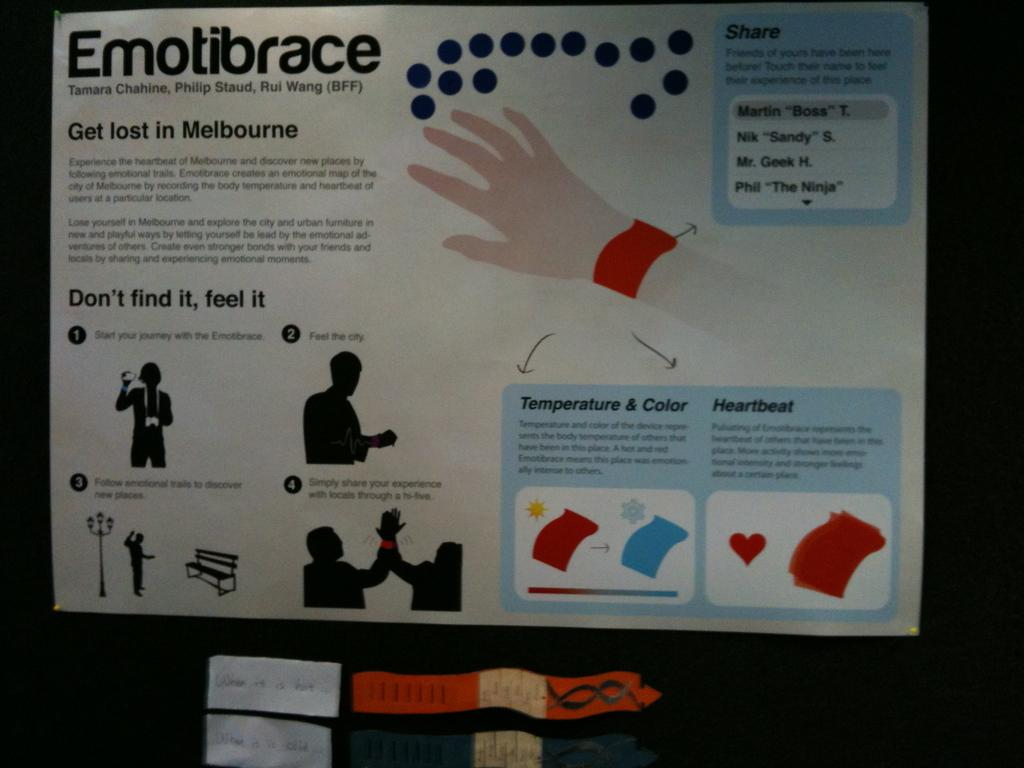<image>
Describe the image concisely. a poster with the word Emotibrace at the top 